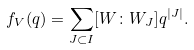<formula> <loc_0><loc_0><loc_500><loc_500>f _ { V } ( q ) = \sum _ { J \subset I } [ W \colon W _ { J } ] q ^ { | J | } .</formula> 